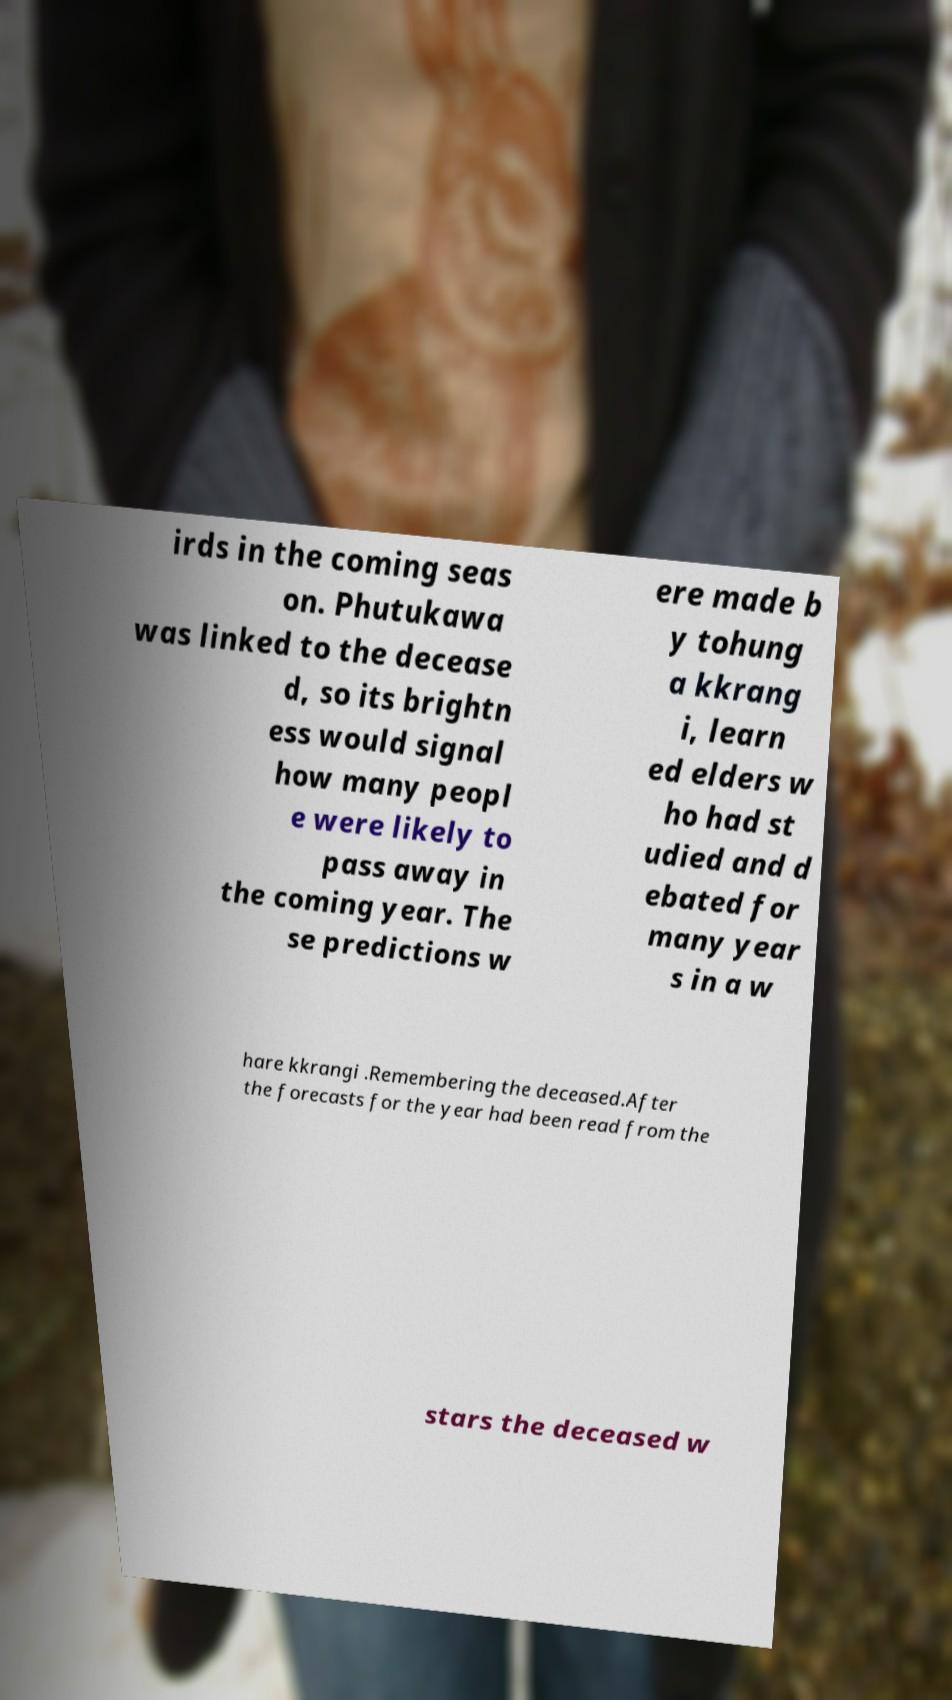Could you assist in decoding the text presented in this image and type it out clearly? irds in the coming seas on. Phutukawa was linked to the decease d, so its brightn ess would signal how many peopl e were likely to pass away in the coming year. The se predictions w ere made b y tohung a kkrang i, learn ed elders w ho had st udied and d ebated for many year s in a w hare kkrangi .Remembering the deceased.After the forecasts for the year had been read from the stars the deceased w 